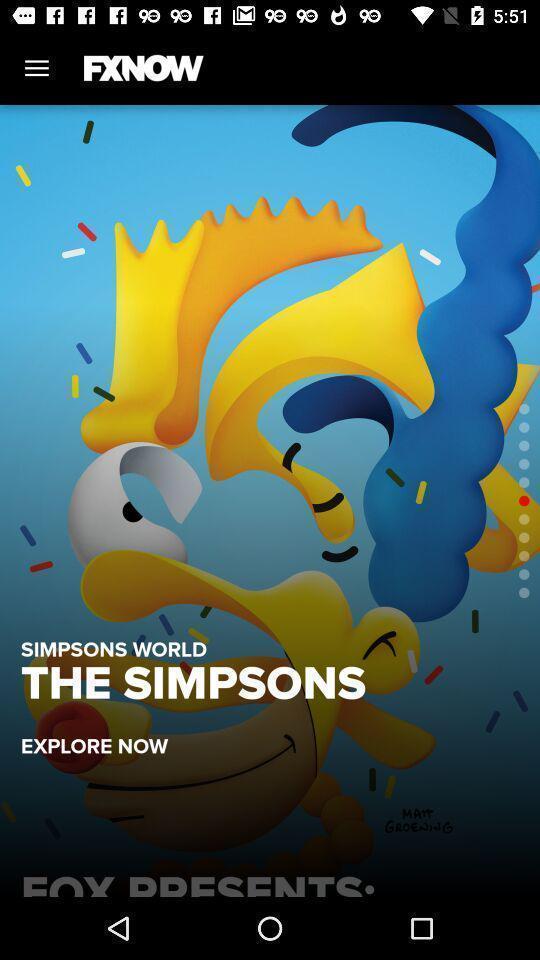What is the overall content of this screenshot? Simpsons show on a movie app. 